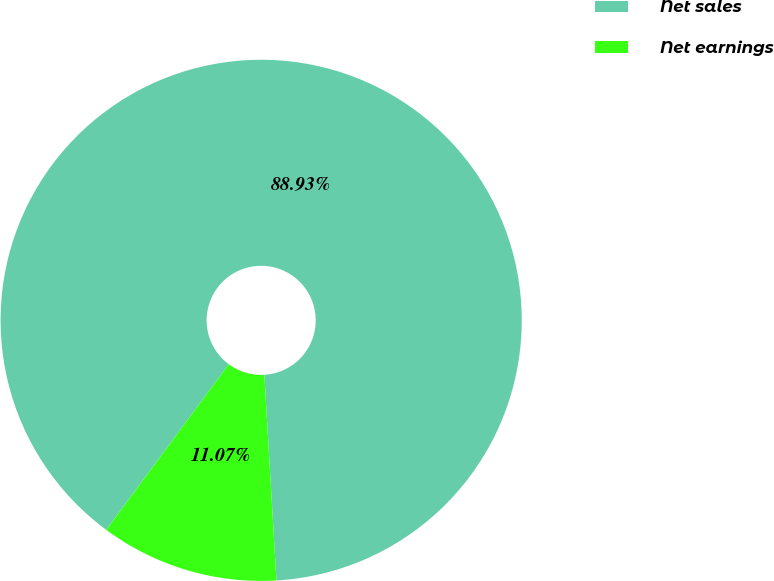Convert chart to OTSL. <chart><loc_0><loc_0><loc_500><loc_500><pie_chart><fcel>Net sales<fcel>Net earnings<nl><fcel>88.93%<fcel>11.07%<nl></chart> 